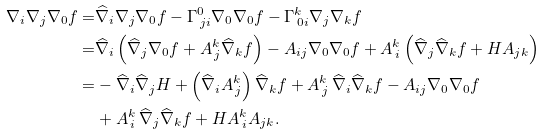<formula> <loc_0><loc_0><loc_500><loc_500>\nabla _ { i } \nabla _ { j } \nabla _ { 0 } f = & \widehat { \nabla } _ { i } \nabla _ { j } \nabla _ { 0 } f - \Gamma ^ { 0 } _ { \, j i } \nabla _ { 0 } \nabla _ { 0 } f - \Gamma ^ { k } _ { \, 0 i } \nabla _ { j } \nabla _ { k } f \\ = & \widehat { \nabla } _ { i } \left ( \widehat { \nabla } _ { j } \nabla _ { 0 } f + A ^ { k } _ { \, j } \widehat { \nabla } _ { k } f \right ) - A _ { i j } \nabla _ { 0 } \nabla _ { 0 } f + A ^ { k } _ { \, i } \left ( \widehat { \nabla } _ { j } \widehat { \nabla } _ { k } f + H A _ { j k } \right ) \\ = & - \widehat { \nabla } _ { i } \widehat { \nabla } _ { j } H + \left ( \widehat { \nabla } _ { i } A ^ { k } _ { \, j } \right ) \widehat { \nabla } _ { k } f + A ^ { k } _ { \, j } \, \widehat { \nabla } _ { i } \widehat { \nabla } _ { k } f - A _ { i j } \nabla _ { 0 } \nabla _ { 0 } f \\ & + A ^ { k } _ { \, i } \, \widehat { \nabla } _ { j } \widehat { \nabla } _ { k } f + H A ^ { k } _ { \, i } A _ { j k } .</formula> 